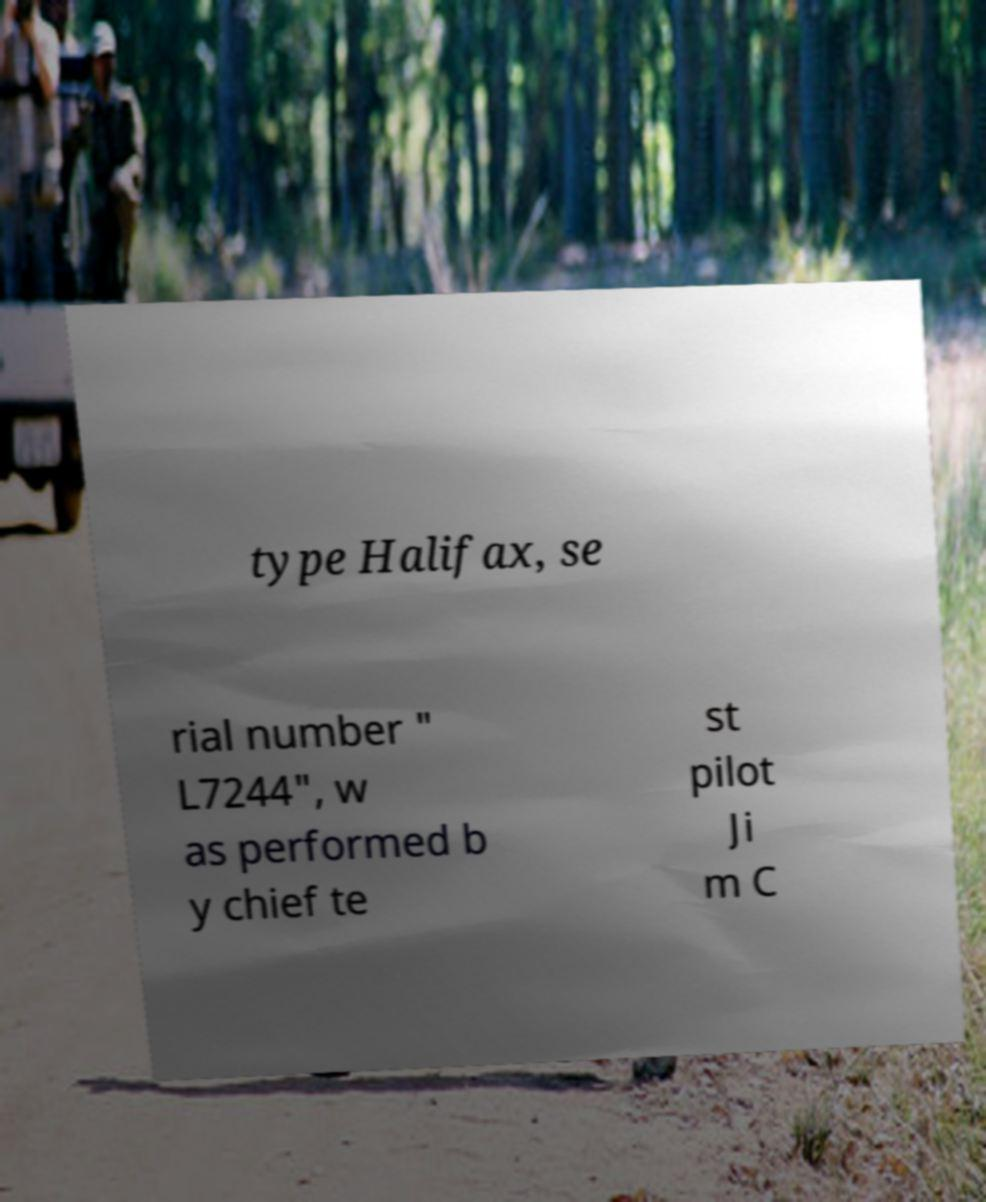For documentation purposes, I need the text within this image transcribed. Could you provide that? type Halifax, se rial number " L7244", w as performed b y chief te st pilot Ji m C 